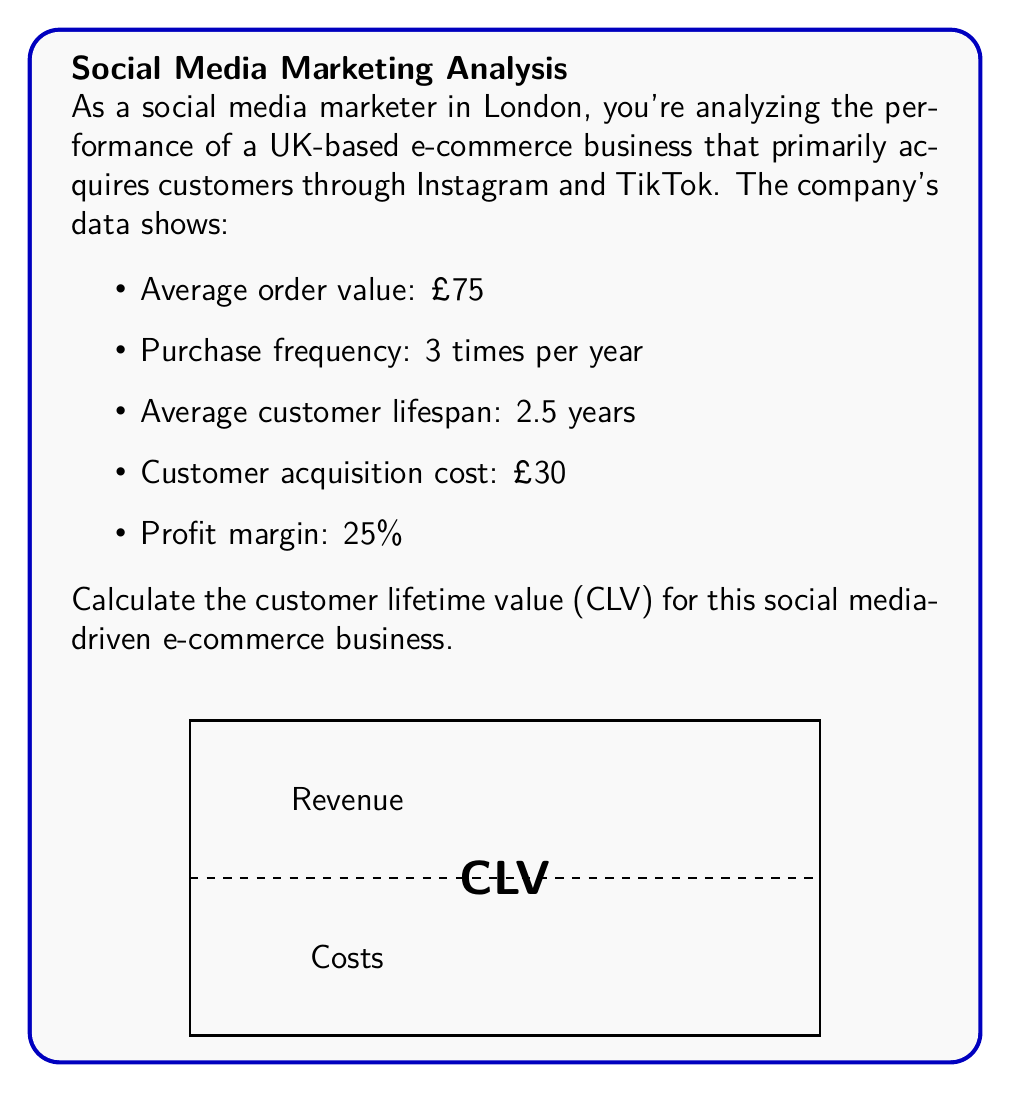Show me your answer to this math problem. To calculate the Customer Lifetime Value (CLV), we'll use the following formula:

$$ CLV = (AOV \times F \times L \times M) - CAC $$

Where:
- AOV = Average Order Value
- F = Purchase Frequency (per year)
- L = Average Customer Lifespan (in years)
- M = Profit Margin (as a decimal)
- CAC = Customer Acquisition Cost

Let's plug in the values:

1. Calculate the total revenue per customer:
   $$ Revenue = AOV \times F \times L = £75 \times 3 \times 2.5 = £562.50 $$

2. Calculate the profit from this revenue:
   $$ Profit = Revenue \times M = £562.50 \times 0.25 = £140.625 $$

3. Subtract the customer acquisition cost:
   $$ CLV = Profit - CAC = £140.625 - £30 = £110.625 $$

Therefore, the Customer Lifetime Value is £110.625.
Answer: £110.63 